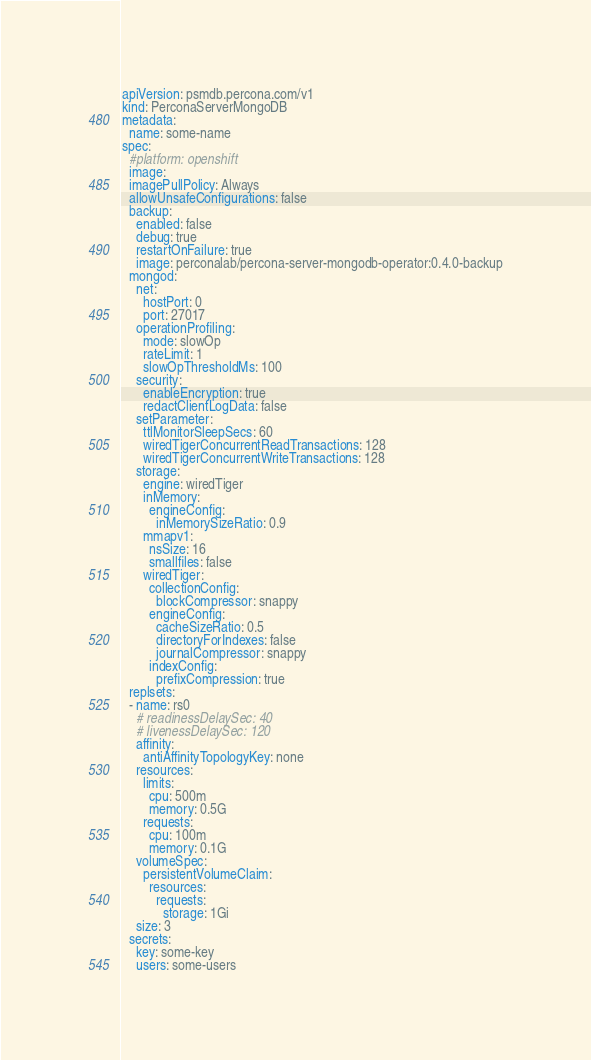<code> <loc_0><loc_0><loc_500><loc_500><_YAML_>apiVersion: psmdb.percona.com/v1
kind: PerconaServerMongoDB
metadata:
  name: some-name
spec:
  #platform: openshift
  image:
  imagePullPolicy: Always
  allowUnsafeConfigurations: false
  backup:
    enabled: false
    debug: true
    restartOnFailure: true
    image: perconalab/percona-server-mongodb-operator:0.4.0-backup
  mongod:
    net:
      hostPort: 0
      port: 27017
    operationProfiling:
      mode: slowOp
      rateLimit: 1
      slowOpThresholdMs: 100
    security:
      enableEncryption: true
      redactClientLogData: false
    setParameter:
      ttlMonitorSleepSecs: 60
      wiredTigerConcurrentReadTransactions: 128
      wiredTigerConcurrentWriteTransactions: 128
    storage:
      engine: wiredTiger
      inMemory:
        engineConfig:
          inMemorySizeRatio: 0.9
      mmapv1:
        nsSize: 16
        smallfiles: false
      wiredTiger:
        collectionConfig:
          blockCompressor: snappy
        engineConfig:
          cacheSizeRatio: 0.5
          directoryForIndexes: false
          journalCompressor: snappy
        indexConfig:
          prefixCompression: true
  replsets:
  - name: rs0
    # readinessDelaySec: 40
    # livenessDelaySec: 120
    affinity:
      antiAffinityTopologyKey: none
    resources:
      limits:
        cpu: 500m
        memory: 0.5G
      requests:
        cpu: 100m
        memory: 0.1G
    volumeSpec:
      persistentVolumeClaim:
        resources:
          requests:
            storage: 1Gi
    size: 3
  secrets:
    key: some-key
    users: some-users
</code> 